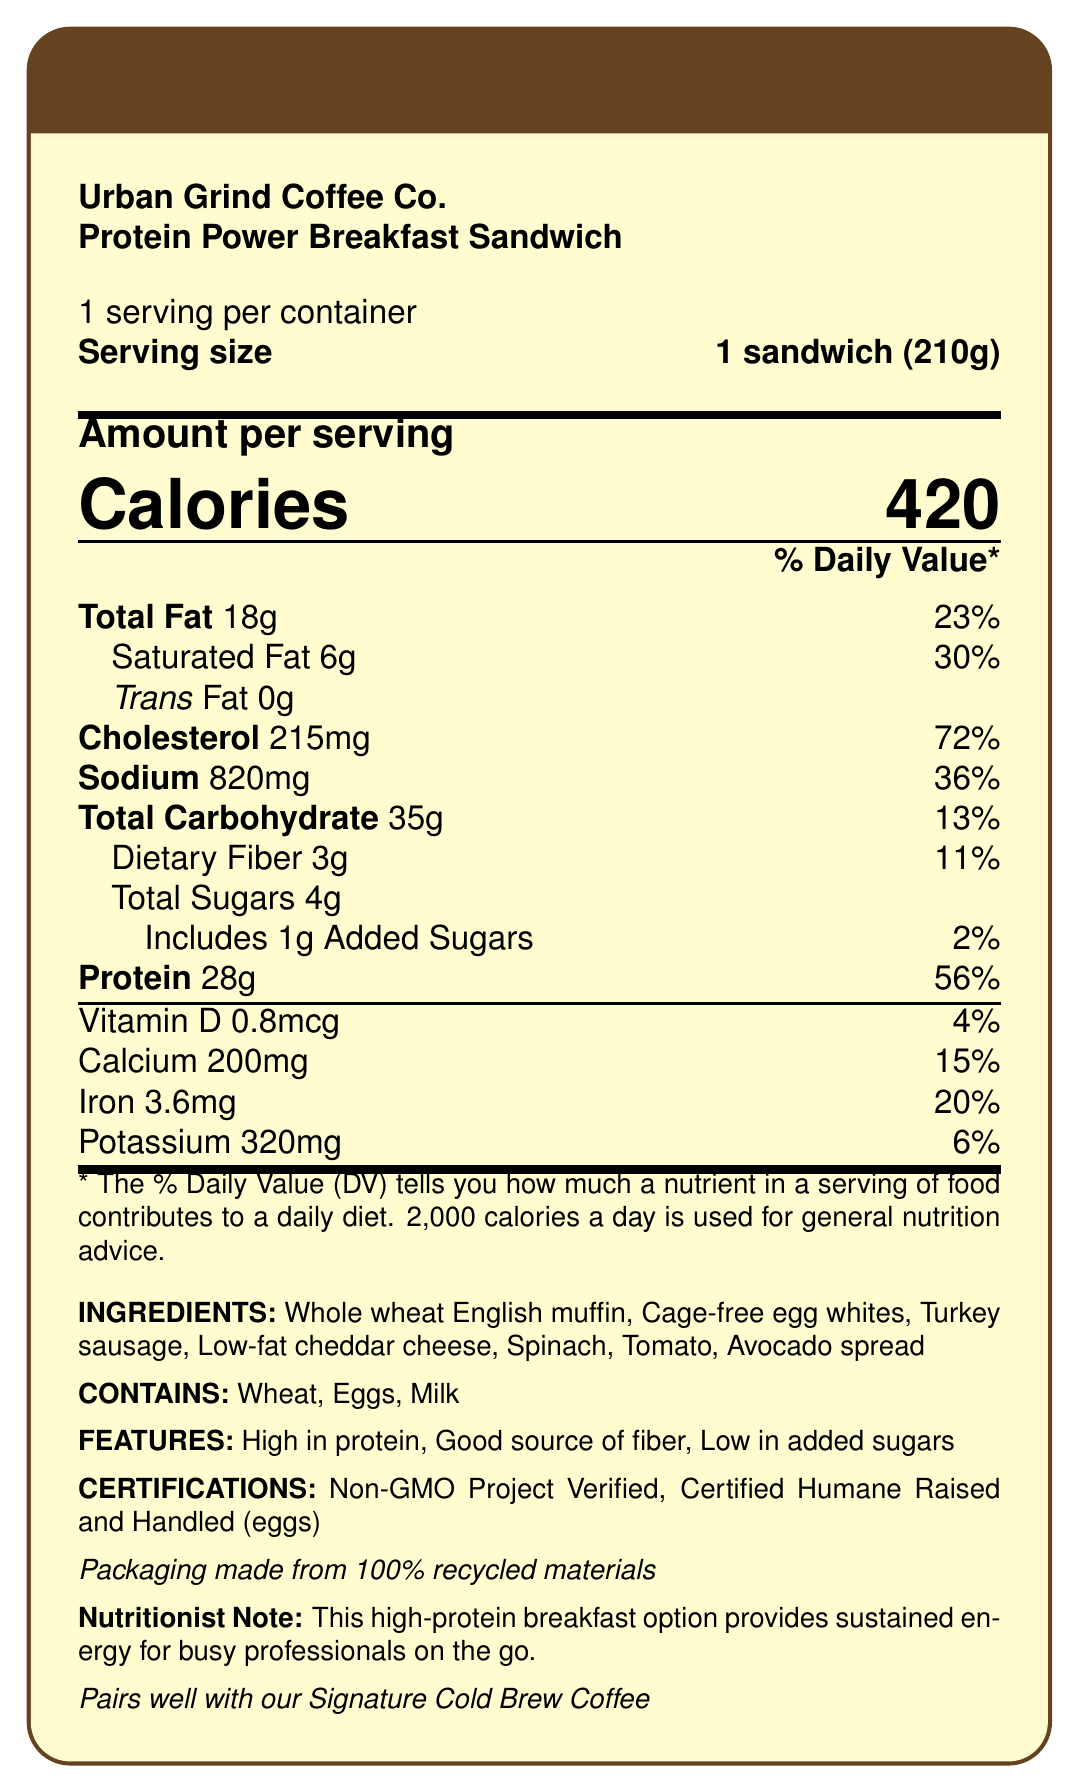What is the serving size of the Protein Power Breakfast Sandwich? The serving size is specified in the document under "Serving size."
Answer: 1 sandwich (210g) How many calories are in one serving of the sandwich? The calories per serving are given as 420 in the "Amount per serving" section.
Answer: 420 calories What percentage of the daily value does the protein content of the sandwich represent? The protein content is listed as 28g, which corresponds to 56% of the daily value.
Answer: 56% List three allergens present in the Protein Power Breakfast Sandwich. The allergens are listed in the "CONTAINS" section of the document.
Answer: Wheat, Eggs, Milk What is the preparation method for the sandwich? The preparation method is mentioned in the document.
Answer: Grilled Identify two certifications the sandwich has received. These certifications are listed under the "CERTIFICATIONS" section.
Answer: Non-GMO Project Verified, Certified Humane Raised and Handled (eggs) What is the calorie count from fat in the sandwich? The calorie count from fat is provided in the document.
Answer: 162 calories True or False: The sandwich contains trans fat. The document indicates that the sandwich contains 0g of trans fat.
Answer: False Which vitamin present in the sandwich has the highest daily value percentage? Iron - 20%, Calcium - 15%, Vitamin D - 4%. The highest value is Iron at 20%.
Answer: Vitamin D Which ingredient is not included in the sandwich? A. Whole wheat English muffin B. Cage-free egg whites C. Tomato D. Bacon The listed ingredients include a whole wheat English muffin, cage-free egg whites, and tomato, but not bacon.
Answer: D. Bacon Which of the following nutritional features does the sandwich have? A. High in protein B. Good source of fiber C. Low in added sugars D. All of the above "High in protein," "Good source of fiber," and "Low in added sugars" are all listed features of the sandwich.
Answer: D. All of the above Can this sandwich be considered suitable for vegetarians? The dietary considerations section indicates it is not suitable for vegans or vegetarians.
Answer: No Summarize the main idea of the document. The document includes nutritional information, ingredients, allergens, features, certifications, and dietary considerations for the sandwich, suggesting it as a high-protein breakfast option.
Answer: The document provides detailed nutrition facts, ingredient list, allergens, and additional features for the Protein Power Breakfast Sandwich from Urban Grind Coffee Co. It highlights the sandwich's high protein content, certifications, and suitability for pescatarians, along with a recommendation to pair it with their Signature Cold Brew Coffee. What is the recommended beverage pairing for the sandwich? The pairing suggestion is mentioned at the bottom of the document.
Answer: Signature Cold Brew Coffee Who is the target consumer for this high-protein breakfast option according to the Nutritionist Note? The Nutritionist Note mentions that the sandwich provides sustained energy for busy professionals on the go.
Answer: Busy professionals on the go How much sodium is in the sandwich? The amount of sodium per serving is listed as 820mg in the document.
Answer: 820mg Does the packaging of the sandwich use recycled materials? The document states that the packaging is made from 100% recycled materials.
Answer: Yes What is the fat percentage of daily value for saturated fat in the sandwich? The saturated fat content is listed as 6g, which corresponds to 30% of the daily value.
Answer: 30% What is the cost of the sandwich? The document does not provide any information about the cost of the sandwich.
Answer: Cannot be determined 